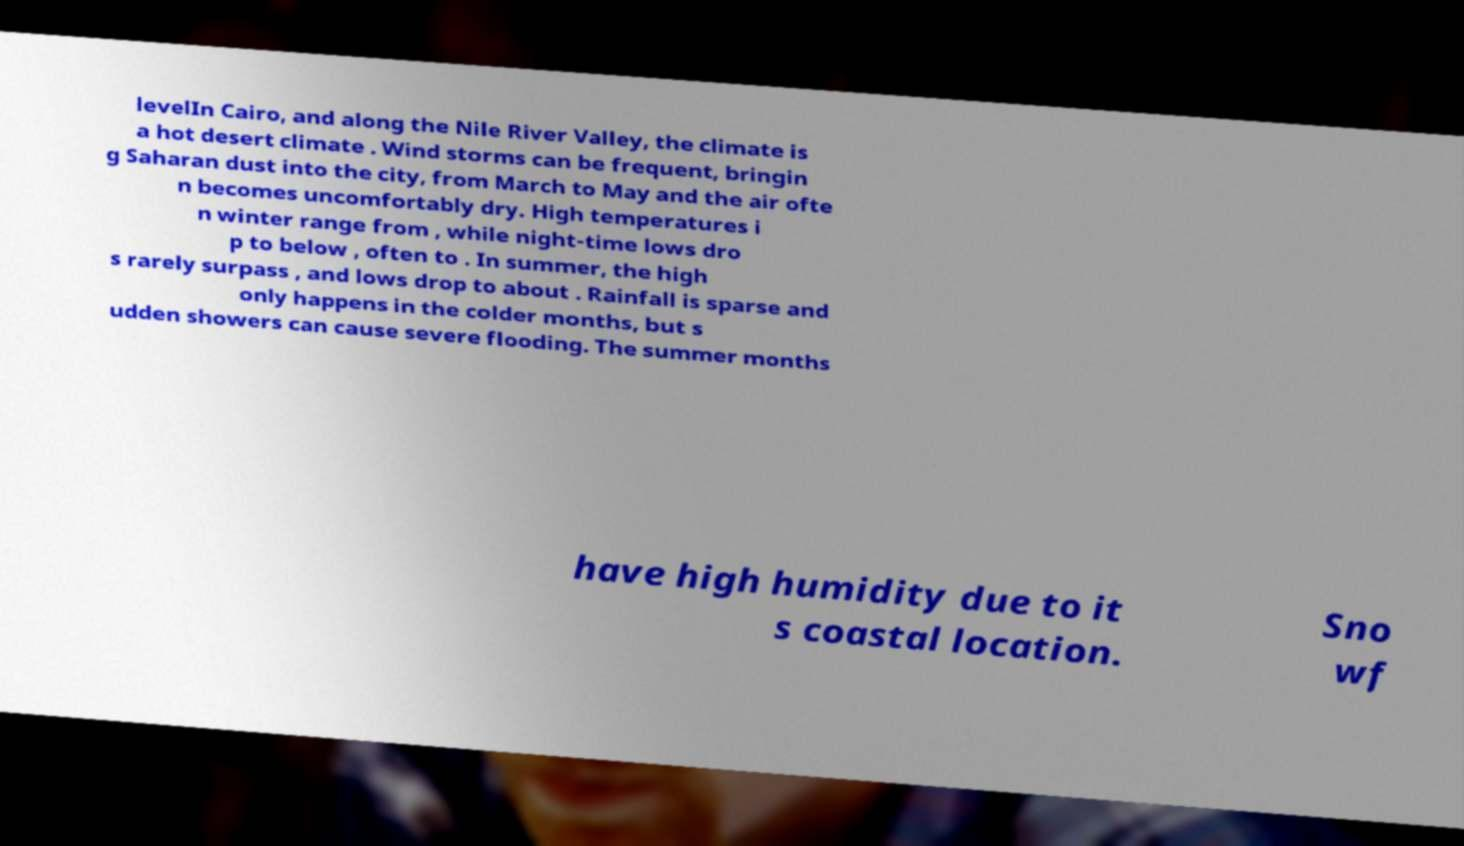Please identify and transcribe the text found in this image. levelIn Cairo, and along the Nile River Valley, the climate is a hot desert climate . Wind storms can be frequent, bringin g Saharan dust into the city, from March to May and the air ofte n becomes uncomfortably dry. High temperatures i n winter range from , while night-time lows dro p to below , often to . In summer, the high s rarely surpass , and lows drop to about . Rainfall is sparse and only happens in the colder months, but s udden showers can cause severe flooding. The summer months have high humidity due to it s coastal location. Sno wf 